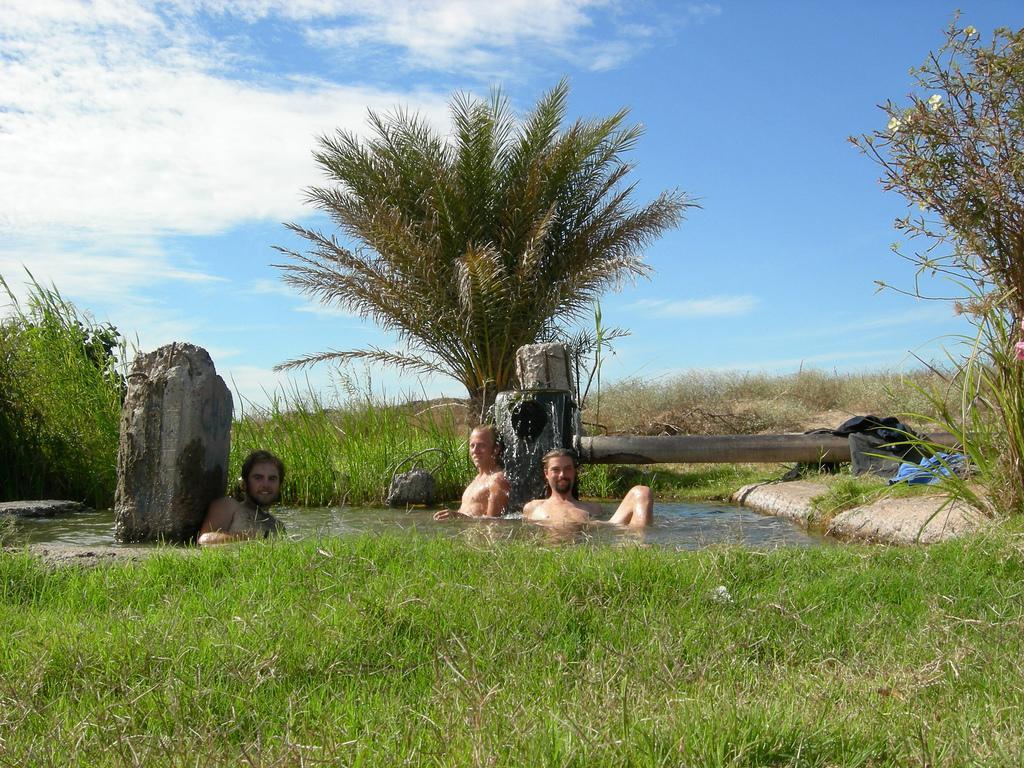How would you summarize this image in a sentence or two? In this picture there are three persons in the water and there is a pipe and there are clothes and there are trees. At the top there is sky and there are clouds. At the bottom there is water and there is grass. 